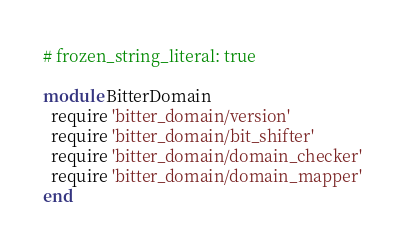Convert code to text. <code><loc_0><loc_0><loc_500><loc_500><_Ruby_># frozen_string_literal: true

module BitterDomain
  require 'bitter_domain/version'
  require 'bitter_domain/bit_shifter'
  require 'bitter_domain/domain_checker'
  require 'bitter_domain/domain_mapper'
end
</code> 